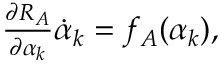Convert formula to latex. <formula><loc_0><loc_0><loc_500><loc_500>\begin{array} { r } { \frac { \partial R _ { A } } { \partial \alpha _ { k } } \dot { \alpha } _ { k } = f _ { A } ( \alpha _ { k } ) , } \end{array}</formula> 